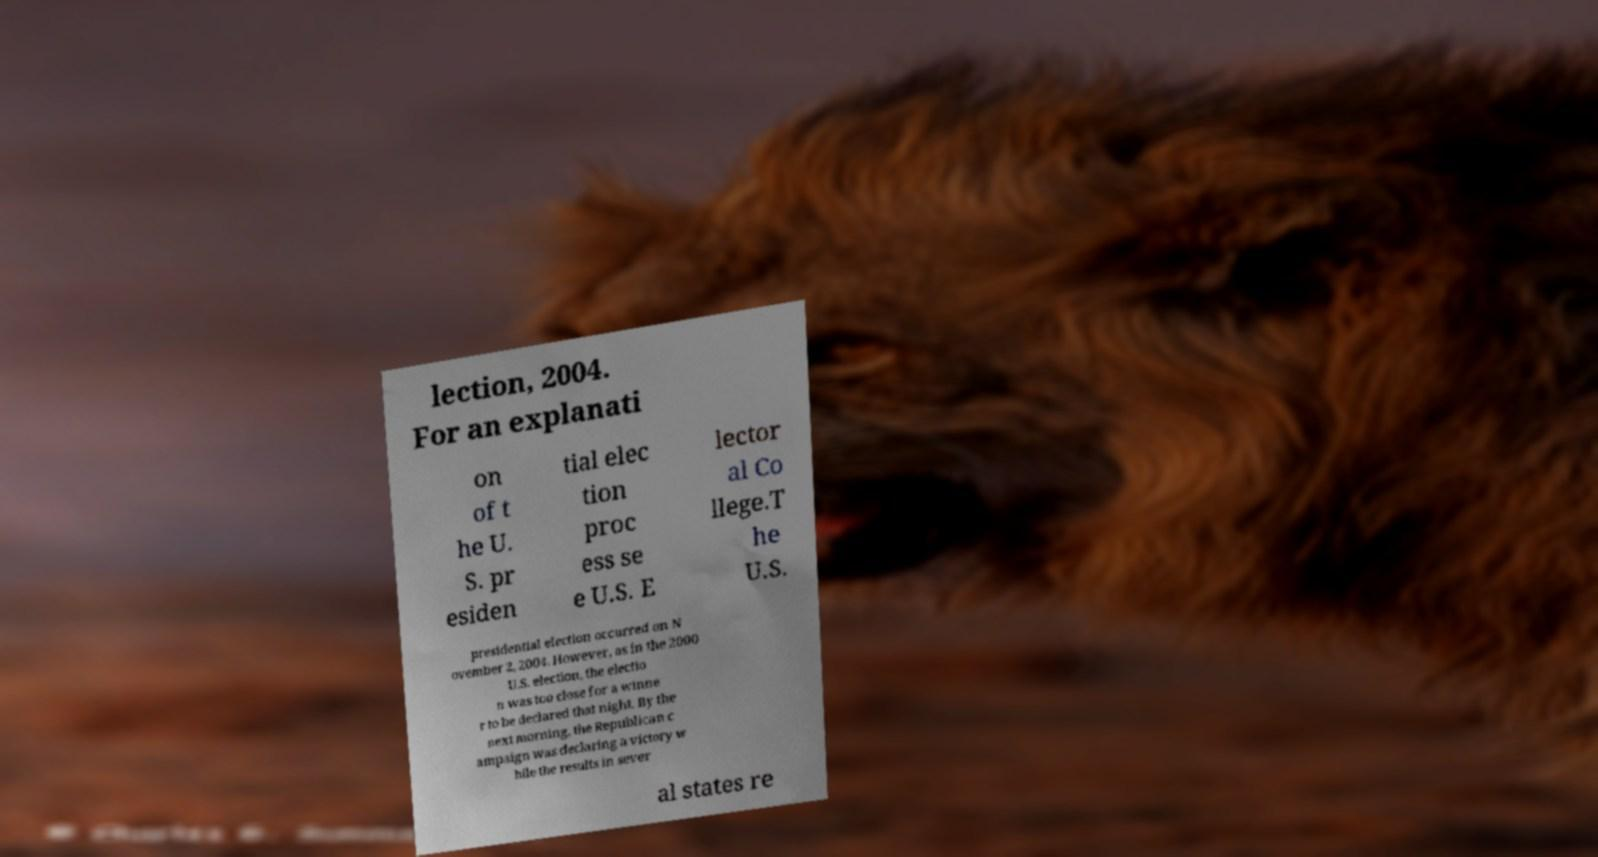There's text embedded in this image that I need extracted. Can you transcribe it verbatim? lection, 2004. For an explanati on of t he U. S. pr esiden tial elec tion proc ess se e U.S. E lector al Co llege.T he U.S. presidential election occurred on N ovember 2, 2004. However, as in the 2000 U.S. election, the electio n was too close for a winne r to be declared that night. By the next morning, the Republican c ampaign was declaring a victory w hile the results in sever al states re 